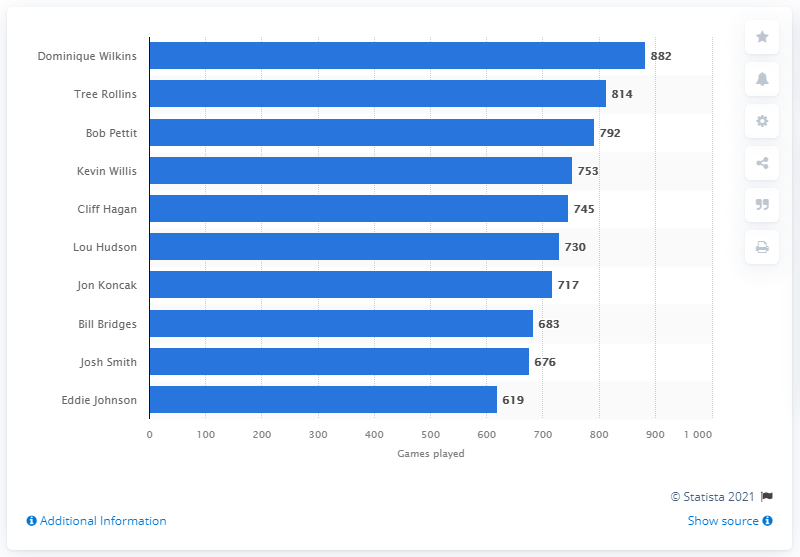Highlight a few significant elements in this photo. Dominique Wilkins, the career games played leader of the Atlanta Hawks, is the individual in question. 